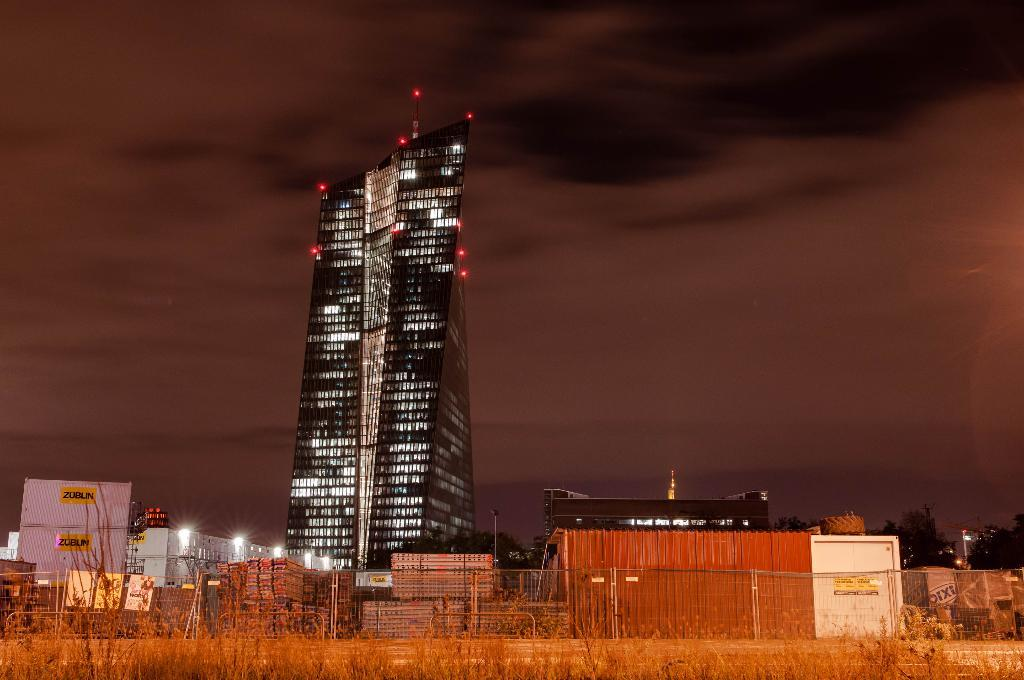What is located at the bottom of the image? There are plants at the bottom of the image. What can be seen in the back of the image? There are railings, buildings, lights, and trees in the back of the image. What is visible in the background of the image? The sky is visible in the background of the image. How many pins can be seen holding up the trees in the image? There are no pins visible in the image; the trees are not being held up by pins. What is the temperature of the hot air balloon in the image? There is no hot air balloon present in the image. 